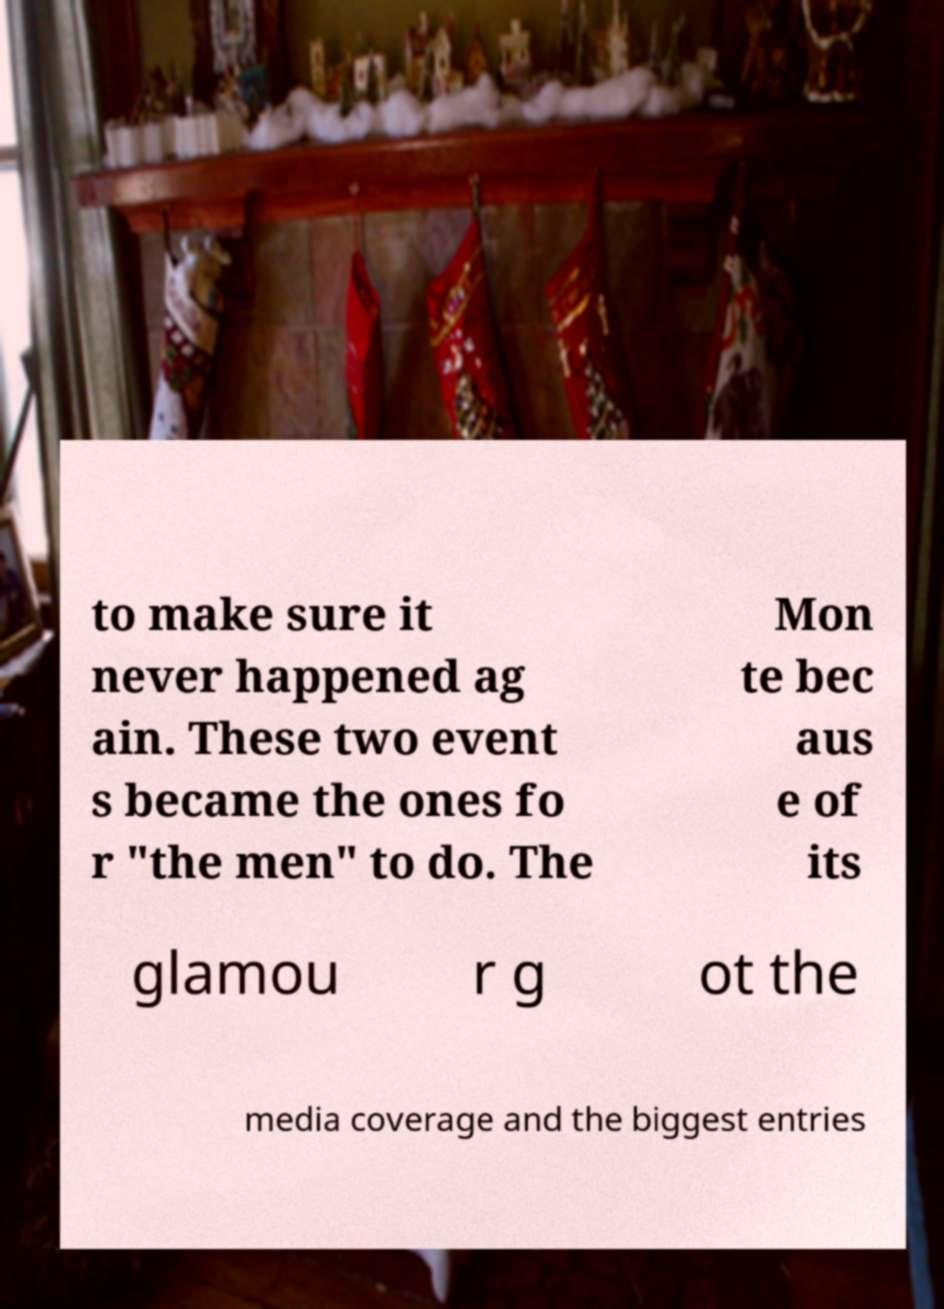Can you read and provide the text displayed in the image?This photo seems to have some interesting text. Can you extract and type it out for me? to make sure it never happened ag ain. These two event s became the ones fo r "the men" to do. The Mon te bec aus e of its glamou r g ot the media coverage and the biggest entries 